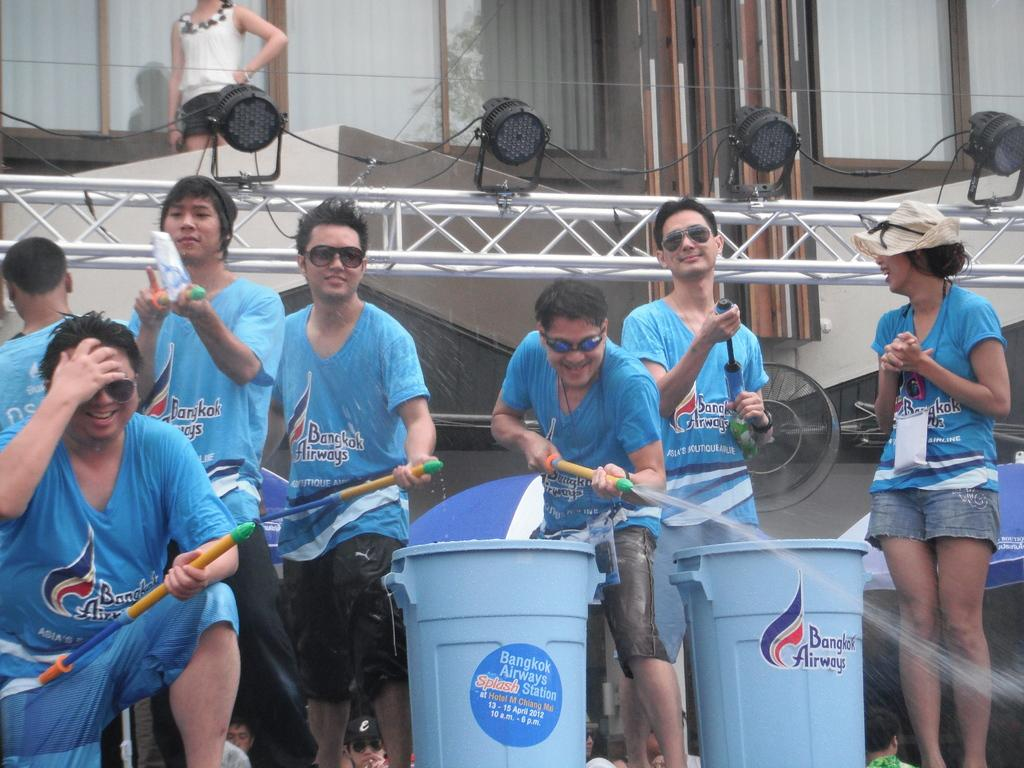<image>
Write a terse but informative summary of the picture. people with water guns in front of Bangkok Airways garbage bins 